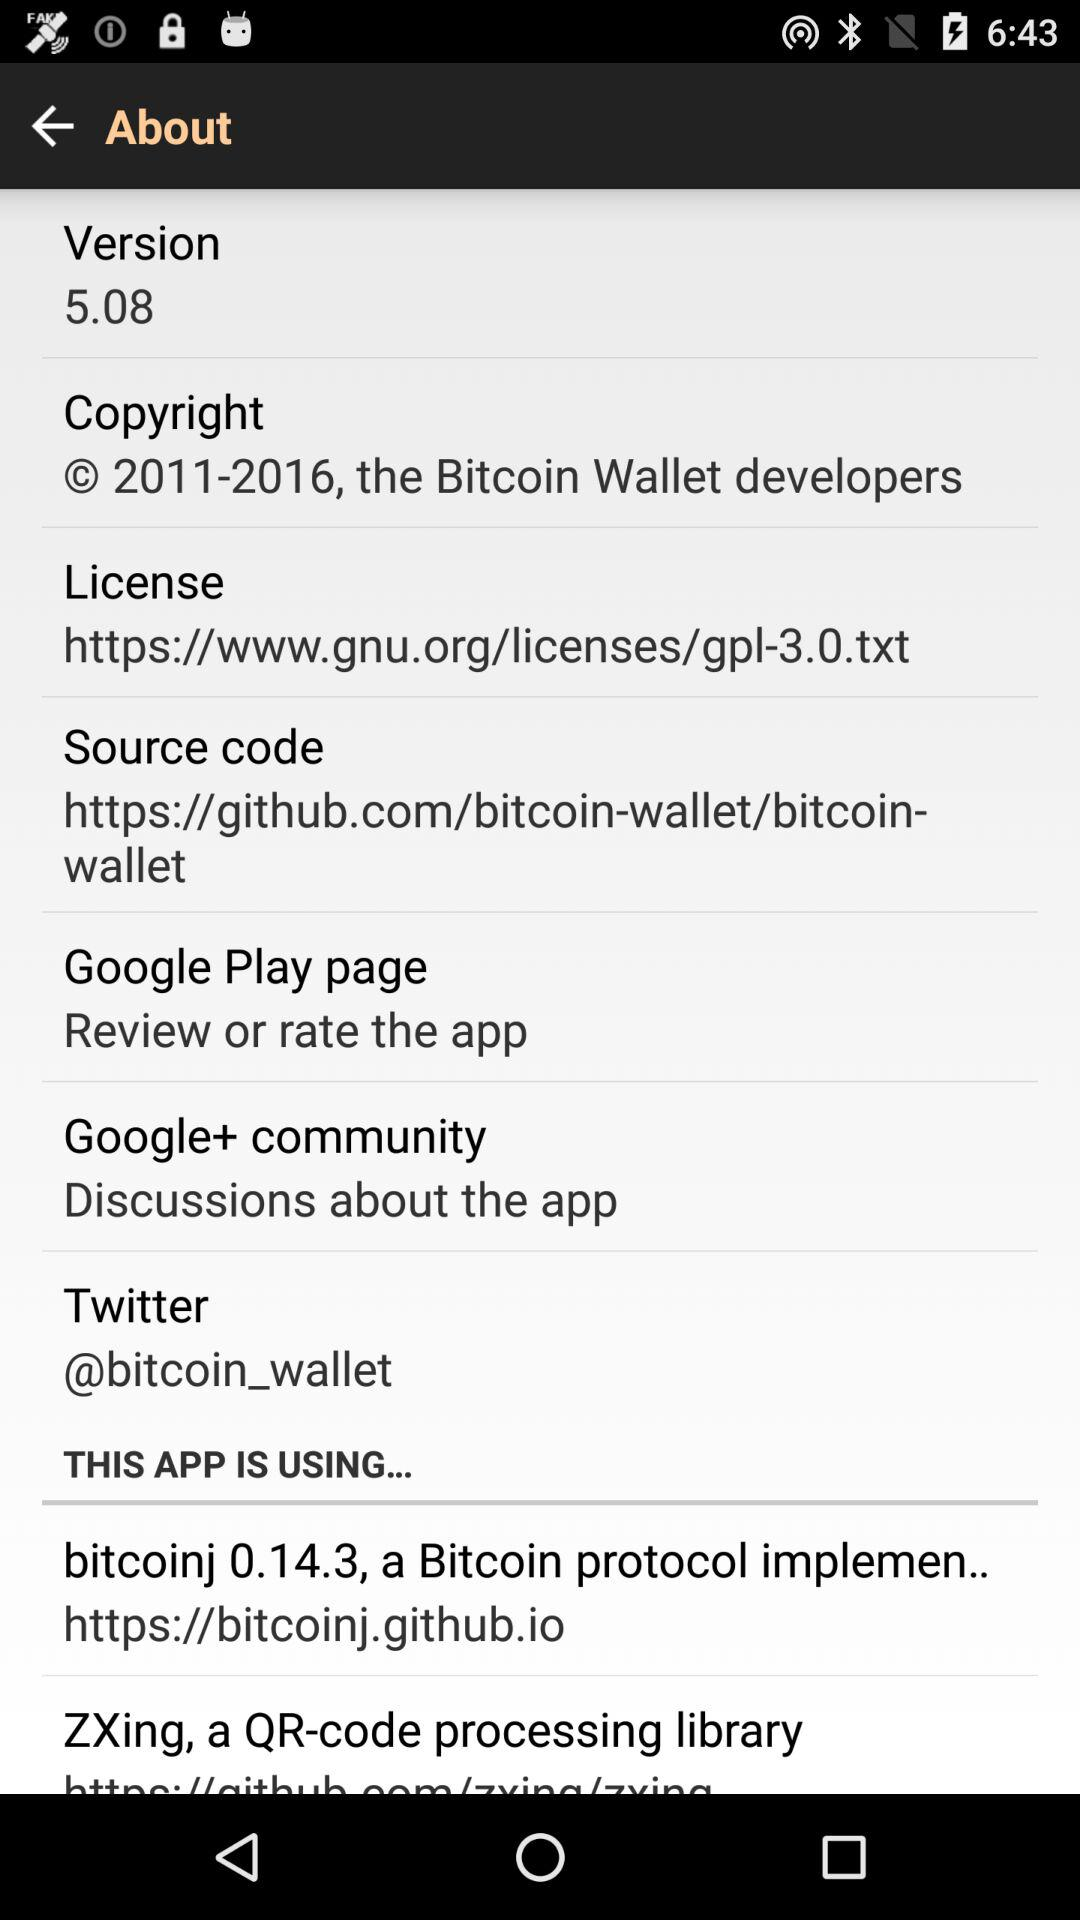Where can I discuss the application? You can discuss the application on the "Google+ community". 